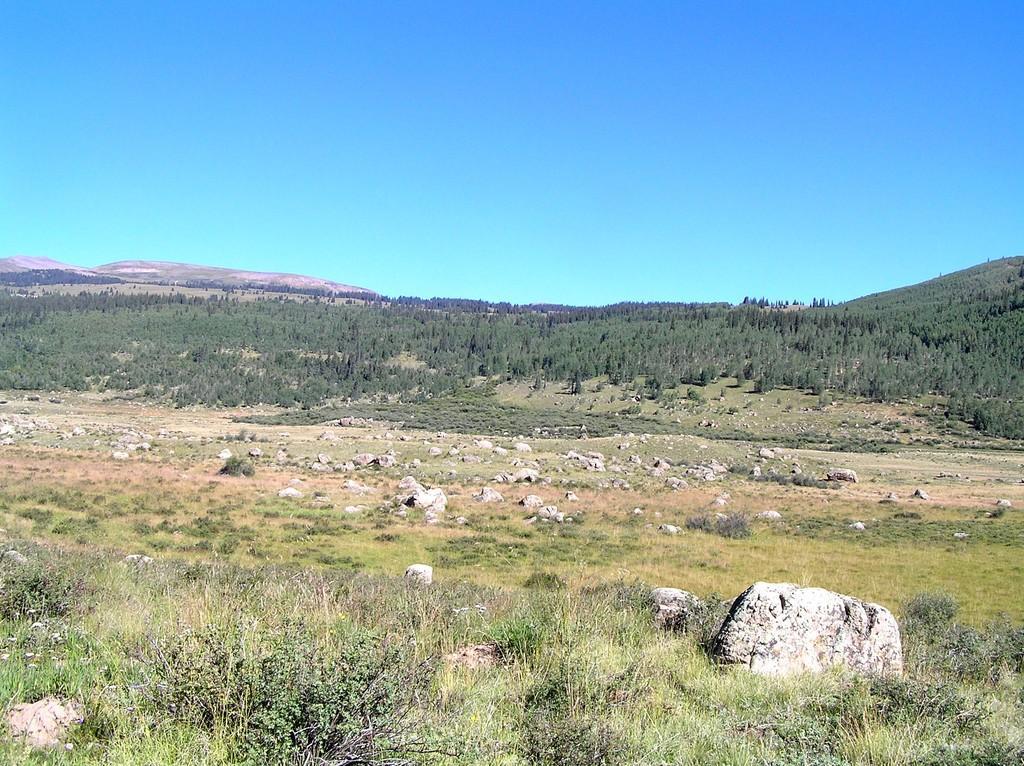Can you describe this image briefly? In this image we can see rocks and plants on the ground. In the background there are trees and sky. 